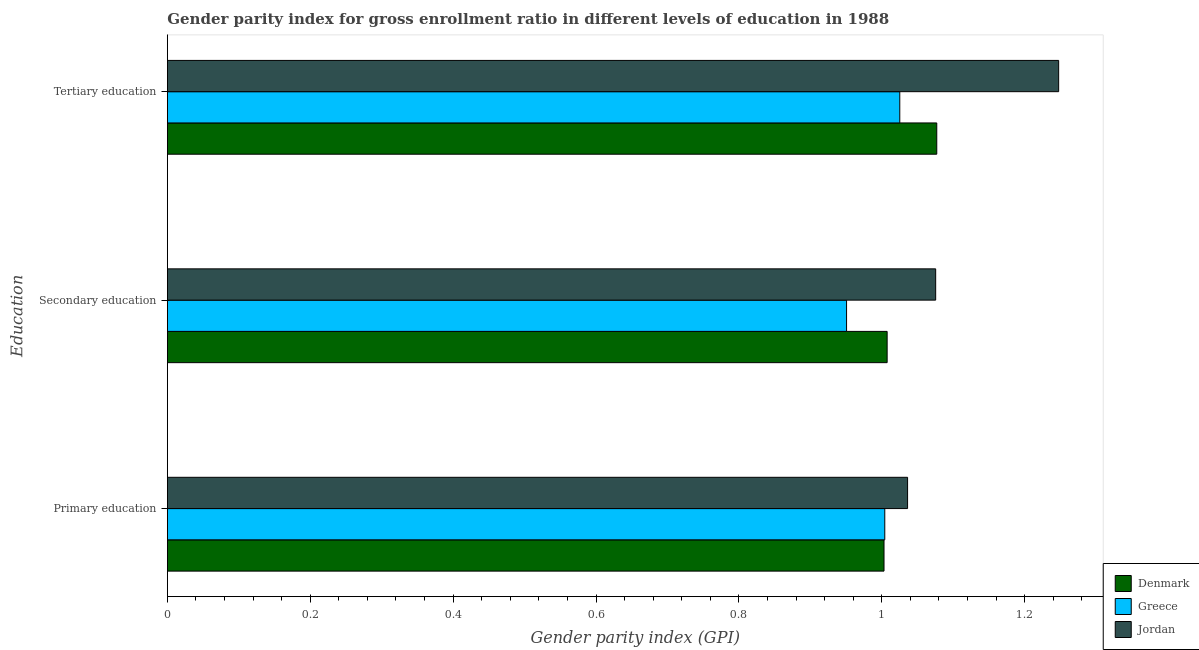How many different coloured bars are there?
Offer a terse response. 3. What is the label of the 2nd group of bars from the top?
Offer a terse response. Secondary education. What is the gender parity index in tertiary education in Denmark?
Your answer should be compact. 1.08. Across all countries, what is the maximum gender parity index in secondary education?
Offer a very short reply. 1.08. Across all countries, what is the minimum gender parity index in tertiary education?
Ensure brevity in your answer.  1.03. In which country was the gender parity index in tertiary education maximum?
Make the answer very short. Jordan. In which country was the gender parity index in primary education minimum?
Your answer should be compact. Denmark. What is the total gender parity index in tertiary education in the graph?
Provide a short and direct response. 3.35. What is the difference between the gender parity index in tertiary education in Jordan and that in Greece?
Make the answer very short. 0.22. What is the difference between the gender parity index in tertiary education in Denmark and the gender parity index in primary education in Greece?
Offer a very short reply. 0.07. What is the average gender parity index in tertiary education per country?
Give a very brief answer. 1.12. What is the difference between the gender parity index in secondary education and gender parity index in tertiary education in Jordan?
Give a very brief answer. -0.17. What is the ratio of the gender parity index in primary education in Denmark to that in Greece?
Provide a succinct answer. 1. Is the gender parity index in tertiary education in Denmark less than that in Jordan?
Your answer should be compact. Yes. What is the difference between the highest and the second highest gender parity index in secondary education?
Offer a terse response. 0.07. What is the difference between the highest and the lowest gender parity index in secondary education?
Make the answer very short. 0.12. In how many countries, is the gender parity index in secondary education greater than the average gender parity index in secondary education taken over all countries?
Offer a very short reply. 1. What does the 2nd bar from the top in Tertiary education represents?
Give a very brief answer. Greece. What does the 1st bar from the bottom in Tertiary education represents?
Give a very brief answer. Denmark. Is it the case that in every country, the sum of the gender parity index in primary education and gender parity index in secondary education is greater than the gender parity index in tertiary education?
Offer a very short reply. Yes. How many bars are there?
Your answer should be compact. 9. Are all the bars in the graph horizontal?
Your answer should be compact. Yes. How many countries are there in the graph?
Offer a terse response. 3. What is the difference between two consecutive major ticks on the X-axis?
Your response must be concise. 0.2. Does the graph contain grids?
Give a very brief answer. No. How many legend labels are there?
Offer a terse response. 3. What is the title of the graph?
Offer a terse response. Gender parity index for gross enrollment ratio in different levels of education in 1988. Does "Gambia, The" appear as one of the legend labels in the graph?
Your response must be concise. No. What is the label or title of the X-axis?
Your answer should be compact. Gender parity index (GPI). What is the label or title of the Y-axis?
Your answer should be compact. Education. What is the Gender parity index (GPI) of Denmark in Primary education?
Offer a very short reply. 1. What is the Gender parity index (GPI) in Greece in Primary education?
Make the answer very short. 1. What is the Gender parity index (GPI) in Jordan in Primary education?
Your response must be concise. 1.04. What is the Gender parity index (GPI) in Denmark in Secondary education?
Provide a succinct answer. 1.01. What is the Gender parity index (GPI) in Greece in Secondary education?
Keep it short and to the point. 0.95. What is the Gender parity index (GPI) in Jordan in Secondary education?
Offer a very short reply. 1.08. What is the Gender parity index (GPI) of Denmark in Tertiary education?
Provide a succinct answer. 1.08. What is the Gender parity index (GPI) in Greece in Tertiary education?
Your answer should be very brief. 1.03. What is the Gender parity index (GPI) of Jordan in Tertiary education?
Offer a very short reply. 1.25. Across all Education, what is the maximum Gender parity index (GPI) of Denmark?
Your answer should be very brief. 1.08. Across all Education, what is the maximum Gender parity index (GPI) in Greece?
Your answer should be very brief. 1.03. Across all Education, what is the maximum Gender parity index (GPI) of Jordan?
Provide a succinct answer. 1.25. Across all Education, what is the minimum Gender parity index (GPI) in Denmark?
Offer a terse response. 1. Across all Education, what is the minimum Gender parity index (GPI) of Greece?
Provide a succinct answer. 0.95. Across all Education, what is the minimum Gender parity index (GPI) in Jordan?
Provide a succinct answer. 1.04. What is the total Gender parity index (GPI) in Denmark in the graph?
Provide a short and direct response. 3.09. What is the total Gender parity index (GPI) of Greece in the graph?
Keep it short and to the point. 2.98. What is the total Gender parity index (GPI) of Jordan in the graph?
Ensure brevity in your answer.  3.36. What is the difference between the Gender parity index (GPI) of Denmark in Primary education and that in Secondary education?
Your answer should be very brief. -0. What is the difference between the Gender parity index (GPI) in Greece in Primary education and that in Secondary education?
Provide a succinct answer. 0.05. What is the difference between the Gender parity index (GPI) in Jordan in Primary education and that in Secondary education?
Provide a short and direct response. -0.04. What is the difference between the Gender parity index (GPI) in Denmark in Primary education and that in Tertiary education?
Provide a short and direct response. -0.07. What is the difference between the Gender parity index (GPI) in Greece in Primary education and that in Tertiary education?
Keep it short and to the point. -0.02. What is the difference between the Gender parity index (GPI) in Jordan in Primary education and that in Tertiary education?
Provide a short and direct response. -0.21. What is the difference between the Gender parity index (GPI) of Denmark in Secondary education and that in Tertiary education?
Your response must be concise. -0.07. What is the difference between the Gender parity index (GPI) in Greece in Secondary education and that in Tertiary education?
Provide a short and direct response. -0.07. What is the difference between the Gender parity index (GPI) in Jordan in Secondary education and that in Tertiary education?
Give a very brief answer. -0.17. What is the difference between the Gender parity index (GPI) in Denmark in Primary education and the Gender parity index (GPI) in Greece in Secondary education?
Your answer should be compact. 0.05. What is the difference between the Gender parity index (GPI) of Denmark in Primary education and the Gender parity index (GPI) of Jordan in Secondary education?
Provide a succinct answer. -0.07. What is the difference between the Gender parity index (GPI) of Greece in Primary education and the Gender parity index (GPI) of Jordan in Secondary education?
Make the answer very short. -0.07. What is the difference between the Gender parity index (GPI) of Denmark in Primary education and the Gender parity index (GPI) of Greece in Tertiary education?
Provide a short and direct response. -0.02. What is the difference between the Gender parity index (GPI) of Denmark in Primary education and the Gender parity index (GPI) of Jordan in Tertiary education?
Ensure brevity in your answer.  -0.24. What is the difference between the Gender parity index (GPI) of Greece in Primary education and the Gender parity index (GPI) of Jordan in Tertiary education?
Your answer should be very brief. -0.24. What is the difference between the Gender parity index (GPI) of Denmark in Secondary education and the Gender parity index (GPI) of Greece in Tertiary education?
Your answer should be compact. -0.02. What is the difference between the Gender parity index (GPI) in Denmark in Secondary education and the Gender parity index (GPI) in Jordan in Tertiary education?
Make the answer very short. -0.24. What is the difference between the Gender parity index (GPI) in Greece in Secondary education and the Gender parity index (GPI) in Jordan in Tertiary education?
Keep it short and to the point. -0.3. What is the average Gender parity index (GPI) in Denmark per Education?
Make the answer very short. 1.03. What is the average Gender parity index (GPI) of Greece per Education?
Provide a succinct answer. 0.99. What is the average Gender parity index (GPI) in Jordan per Education?
Your answer should be compact. 1.12. What is the difference between the Gender parity index (GPI) in Denmark and Gender parity index (GPI) in Greece in Primary education?
Keep it short and to the point. -0. What is the difference between the Gender parity index (GPI) of Denmark and Gender parity index (GPI) of Jordan in Primary education?
Keep it short and to the point. -0.03. What is the difference between the Gender parity index (GPI) of Greece and Gender parity index (GPI) of Jordan in Primary education?
Provide a succinct answer. -0.03. What is the difference between the Gender parity index (GPI) of Denmark and Gender parity index (GPI) of Greece in Secondary education?
Ensure brevity in your answer.  0.06. What is the difference between the Gender parity index (GPI) of Denmark and Gender parity index (GPI) of Jordan in Secondary education?
Your response must be concise. -0.07. What is the difference between the Gender parity index (GPI) of Greece and Gender parity index (GPI) of Jordan in Secondary education?
Keep it short and to the point. -0.12. What is the difference between the Gender parity index (GPI) of Denmark and Gender parity index (GPI) of Greece in Tertiary education?
Ensure brevity in your answer.  0.05. What is the difference between the Gender parity index (GPI) in Denmark and Gender parity index (GPI) in Jordan in Tertiary education?
Keep it short and to the point. -0.17. What is the difference between the Gender parity index (GPI) in Greece and Gender parity index (GPI) in Jordan in Tertiary education?
Make the answer very short. -0.22. What is the ratio of the Gender parity index (GPI) of Denmark in Primary education to that in Secondary education?
Ensure brevity in your answer.  1. What is the ratio of the Gender parity index (GPI) in Greece in Primary education to that in Secondary education?
Your answer should be very brief. 1.06. What is the ratio of the Gender parity index (GPI) in Jordan in Primary education to that in Secondary education?
Offer a terse response. 0.96. What is the ratio of the Gender parity index (GPI) of Denmark in Primary education to that in Tertiary education?
Provide a succinct answer. 0.93. What is the ratio of the Gender parity index (GPI) of Greece in Primary education to that in Tertiary education?
Your answer should be compact. 0.98. What is the ratio of the Gender parity index (GPI) of Jordan in Primary education to that in Tertiary education?
Offer a very short reply. 0.83. What is the ratio of the Gender parity index (GPI) in Denmark in Secondary education to that in Tertiary education?
Your response must be concise. 0.94. What is the ratio of the Gender parity index (GPI) of Greece in Secondary education to that in Tertiary education?
Your answer should be compact. 0.93. What is the ratio of the Gender parity index (GPI) of Jordan in Secondary education to that in Tertiary education?
Your answer should be very brief. 0.86. What is the difference between the highest and the second highest Gender parity index (GPI) of Denmark?
Make the answer very short. 0.07. What is the difference between the highest and the second highest Gender parity index (GPI) in Greece?
Ensure brevity in your answer.  0.02. What is the difference between the highest and the second highest Gender parity index (GPI) in Jordan?
Provide a short and direct response. 0.17. What is the difference between the highest and the lowest Gender parity index (GPI) of Denmark?
Provide a short and direct response. 0.07. What is the difference between the highest and the lowest Gender parity index (GPI) of Greece?
Your response must be concise. 0.07. What is the difference between the highest and the lowest Gender parity index (GPI) in Jordan?
Your answer should be very brief. 0.21. 